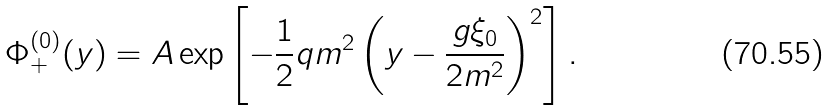Convert formula to latex. <formula><loc_0><loc_0><loc_500><loc_500>\Phi _ { + } ^ { ( 0 ) } ( y ) = A \exp \left [ - \frac { 1 } { 2 } q m ^ { 2 } \left ( y - \frac { g \xi _ { 0 } } { 2 m ^ { 2 } } \right ) ^ { 2 } \right ] .</formula> 